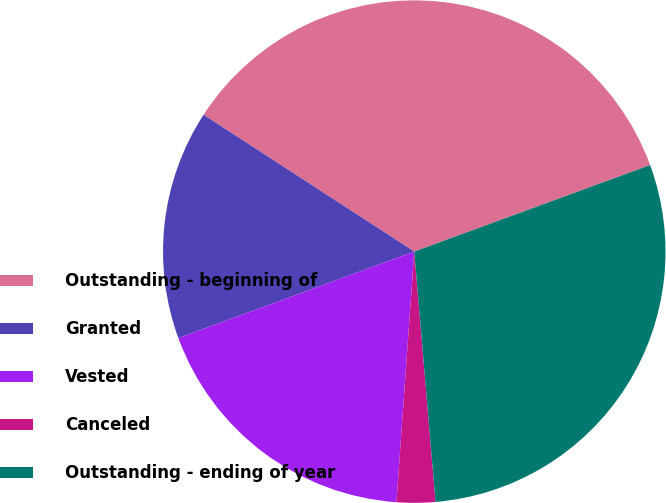Convert chart to OTSL. <chart><loc_0><loc_0><loc_500><loc_500><pie_chart><fcel>Outstanding - beginning of<fcel>Granted<fcel>Vested<fcel>Canceled<fcel>Outstanding - ending of year<nl><fcel>35.24%<fcel>14.76%<fcel>18.28%<fcel>2.48%<fcel>29.25%<nl></chart> 